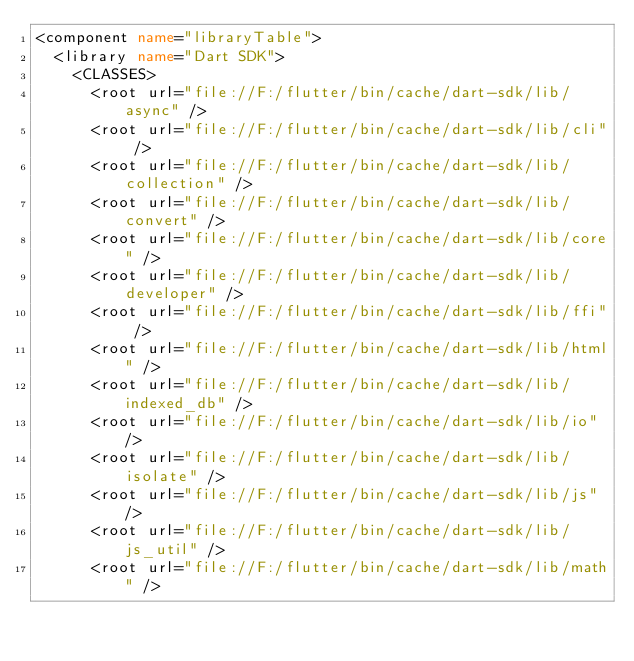Convert code to text. <code><loc_0><loc_0><loc_500><loc_500><_XML_><component name="libraryTable">
  <library name="Dart SDK">
    <CLASSES>
      <root url="file://F:/flutter/bin/cache/dart-sdk/lib/async" />
      <root url="file://F:/flutter/bin/cache/dart-sdk/lib/cli" />
      <root url="file://F:/flutter/bin/cache/dart-sdk/lib/collection" />
      <root url="file://F:/flutter/bin/cache/dart-sdk/lib/convert" />
      <root url="file://F:/flutter/bin/cache/dart-sdk/lib/core" />
      <root url="file://F:/flutter/bin/cache/dart-sdk/lib/developer" />
      <root url="file://F:/flutter/bin/cache/dart-sdk/lib/ffi" />
      <root url="file://F:/flutter/bin/cache/dart-sdk/lib/html" />
      <root url="file://F:/flutter/bin/cache/dart-sdk/lib/indexed_db" />
      <root url="file://F:/flutter/bin/cache/dart-sdk/lib/io" />
      <root url="file://F:/flutter/bin/cache/dart-sdk/lib/isolate" />
      <root url="file://F:/flutter/bin/cache/dart-sdk/lib/js" />
      <root url="file://F:/flutter/bin/cache/dart-sdk/lib/js_util" />
      <root url="file://F:/flutter/bin/cache/dart-sdk/lib/math" /></code> 